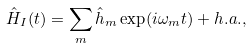Convert formula to latex. <formula><loc_0><loc_0><loc_500><loc_500>\hat { H } _ { I } ( t ) = \sum _ { m } \hat { h } _ { m } \exp ( i \omega _ { m } t ) + h . a . ,</formula> 